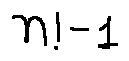Convert formula to latex. <formula><loc_0><loc_0><loc_500><loc_500>n ! - 1</formula> 